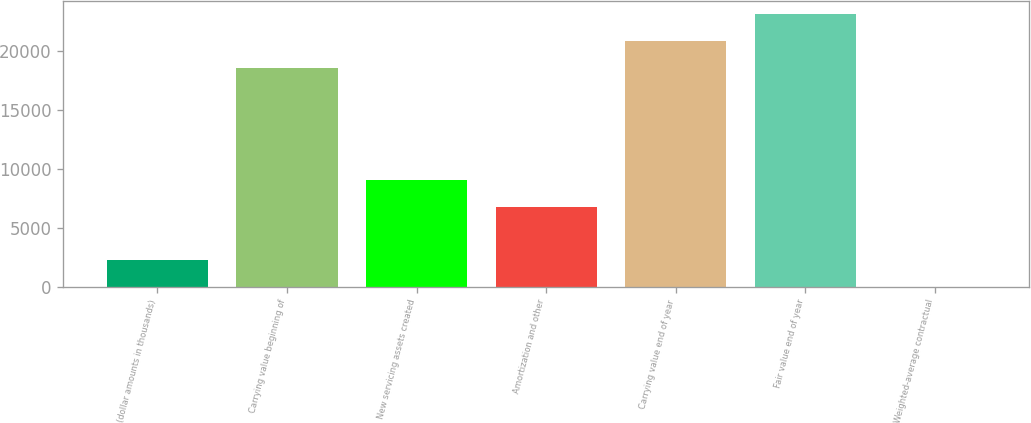Convert chart to OTSL. <chart><loc_0><loc_0><loc_500><loc_500><bar_chart><fcel>(dollar amounts in thousands)<fcel>Carrying value beginning of<fcel>New servicing assets created<fcel>Amortization and other<fcel>Carrying value end of year<fcel>Fair value end of year<fcel>Weighted-average contractual<nl><fcel>2267.87<fcel>18536<fcel>9065.57<fcel>6801<fcel>20800.6<fcel>23065.1<fcel>3.3<nl></chart> 